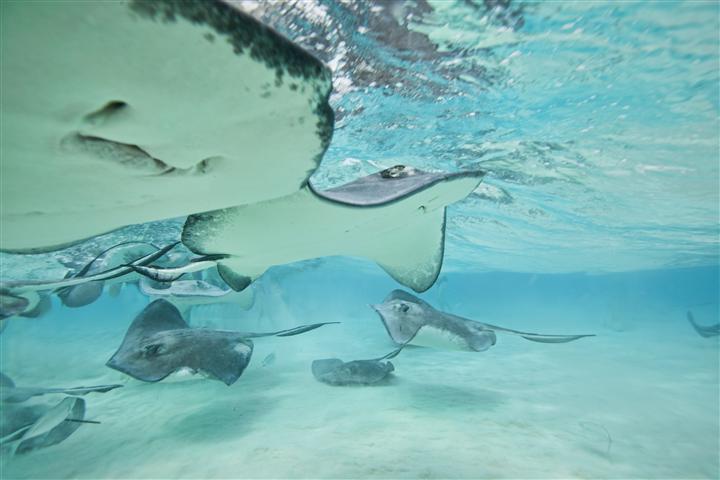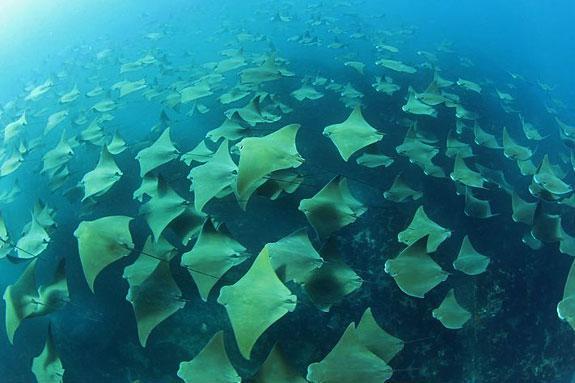The first image is the image on the left, the second image is the image on the right. Analyze the images presented: Is the assertion "There is a man, standing among the manta rays." valid? Answer yes or no. No. The first image is the image on the left, the second image is the image on the right. Given the left and right images, does the statement "At least one human is standig in water where stingray are swimming." hold true? Answer yes or no. No. 